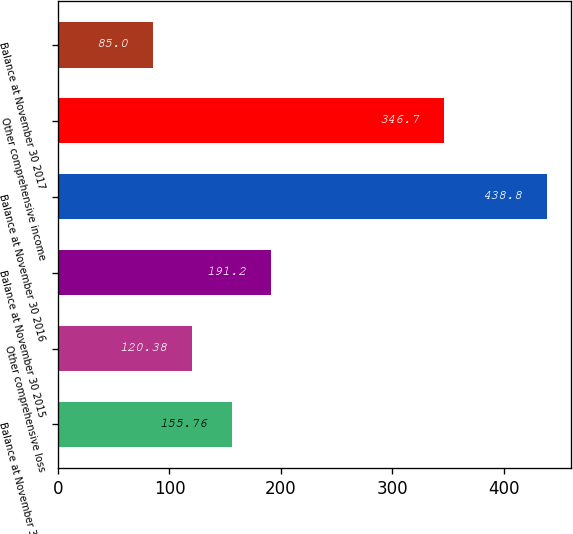Convert chart to OTSL. <chart><loc_0><loc_0><loc_500><loc_500><bar_chart><fcel>Balance at November 30 2014<fcel>Other comprehensive loss<fcel>Balance at November 30 2015<fcel>Balance at November 30 2016<fcel>Other comprehensive income<fcel>Balance at November 30 2017<nl><fcel>155.76<fcel>120.38<fcel>191.2<fcel>438.8<fcel>346.7<fcel>85<nl></chart> 